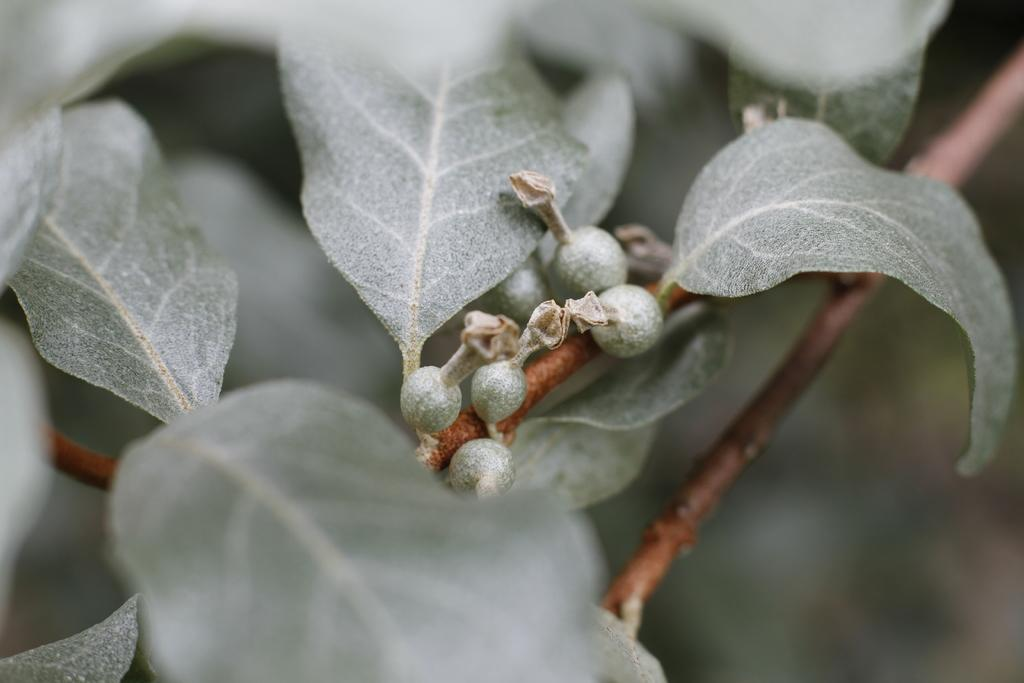What is the main focus of the image? The image is a zoom-in of a stem. What can be seen attached to the stem? There is a leaf visible in the image. Is there anything else visible on the stem? Yes, there is a fruit visible in the image. What type of bucket can be seen holding the fruit in the image? There is no bucket present in the image; the fruit is directly attached to the stem. How many oranges are visible in the image? There are no oranges visible in the image; the fruit is not specified. 